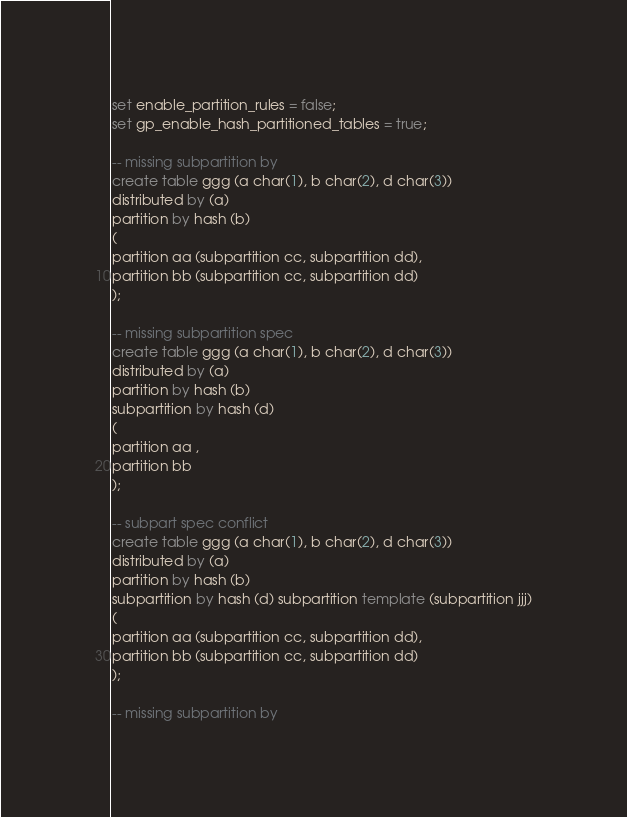<code> <loc_0><loc_0><loc_500><loc_500><_SQL_>set enable_partition_rules = false;
set gp_enable_hash_partitioned_tables = true;

-- missing subpartition by
create table ggg (a char(1), b char(2), d char(3))
distributed by (a)
partition by hash (b)
(
partition aa (subpartition cc, subpartition dd),
partition bb (subpartition cc, subpartition dd)
);

-- missing subpartition spec
create table ggg (a char(1), b char(2), d char(3))
distributed by (a)
partition by hash (b)
subpartition by hash (d) 
(
partition aa ,
partition bb 
);

-- subpart spec conflict
create table ggg (a char(1), b char(2), d char(3))
distributed by (a)
partition by hash (b) 
subpartition by hash (d) subpartition template (subpartition jjj)
(
partition aa (subpartition cc, subpartition dd),
partition bb (subpartition cc, subpartition dd)
);

-- missing subpartition by</code> 